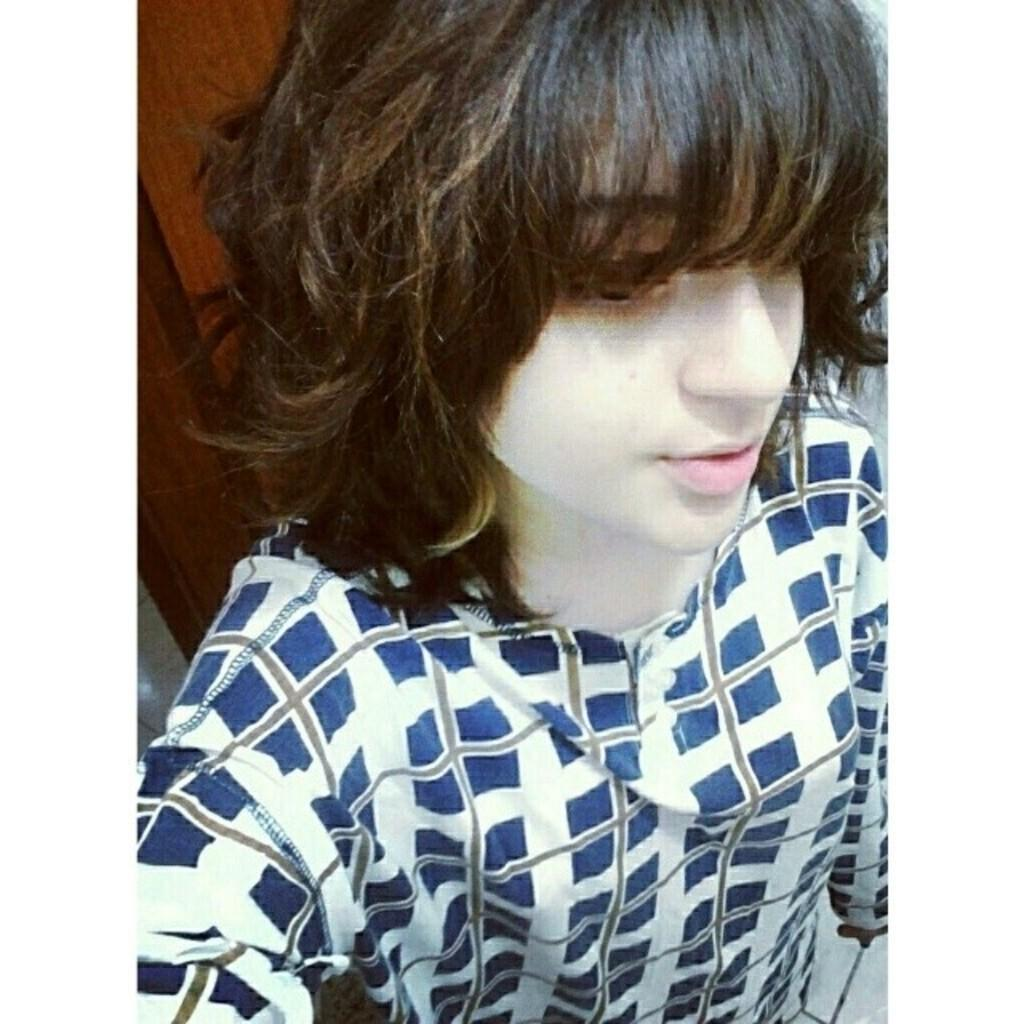What is located in the center of the image? There is a mannequin in the center of the image. What can be seen in the background of the image? There is a wall in the background of the image. What is the tendency of the pet to flock with other animals in the image? There is no pet or other animals present in the image. 